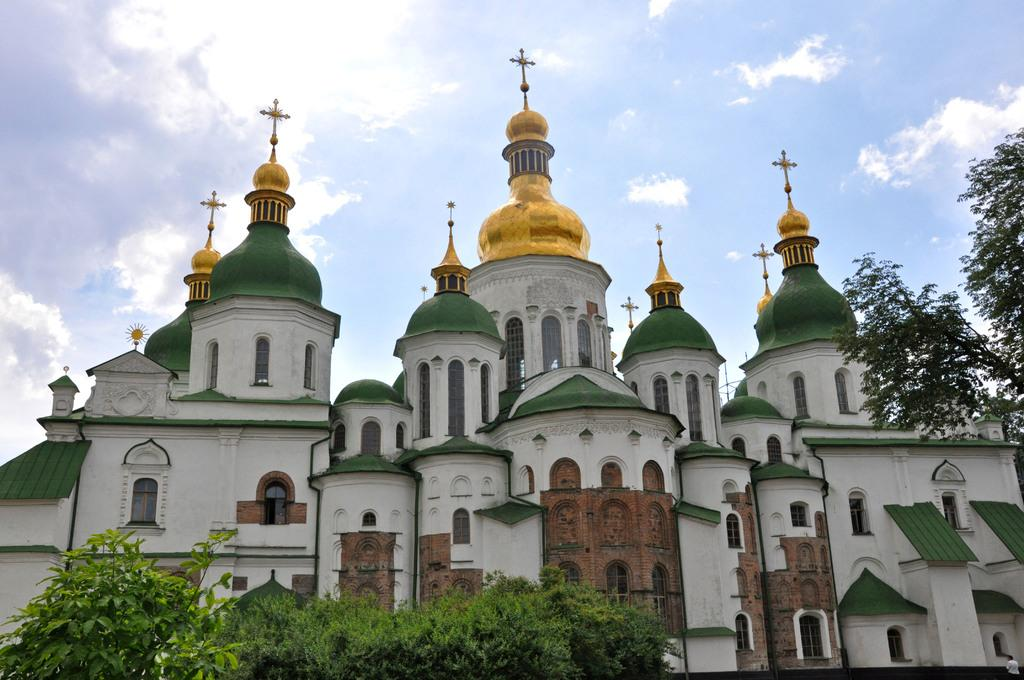What type of vegetation is visible in the front of the image? There are trees in the front of the image. What type of building can be seen in the background of the image? There is a church in the background of the image. How would you describe the sky in the image? The sky is cloudy in the image. What type of relation is depicted between the trees and the church in the image? There is no depiction of a relation between the trees and the church in the image; they are simply separate elements in the scene. Can you tell me how many hospitals are visible in the image? There are no hospitals visible in the image; it features trees and a church. 